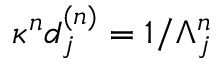Convert formula to latex. <formula><loc_0><loc_0><loc_500><loc_500>\kappa ^ { n } d _ { j } ^ { ( n ) } = 1 / \Lambda _ { j } ^ { n }</formula> 